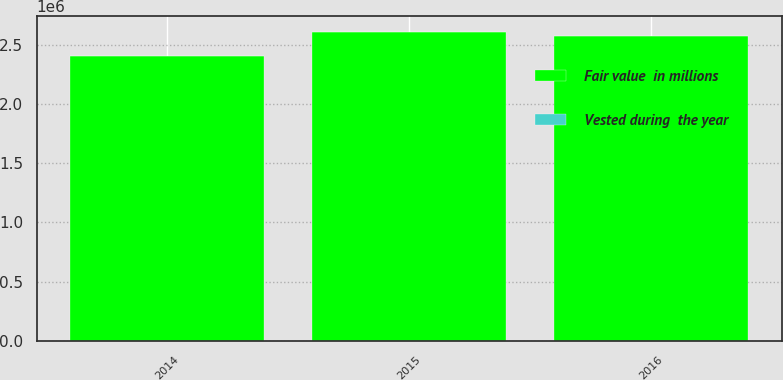<chart> <loc_0><loc_0><loc_500><loc_500><stacked_bar_chart><ecel><fcel>2016<fcel>2015<fcel>2014<nl><fcel>Fair value  in millions<fcel>2.57213e+06<fcel>2.61152e+06<fcel>2.40818e+06<nl><fcel>Vested during  the year<fcel>98<fcel>83<fcel>65<nl></chart> 